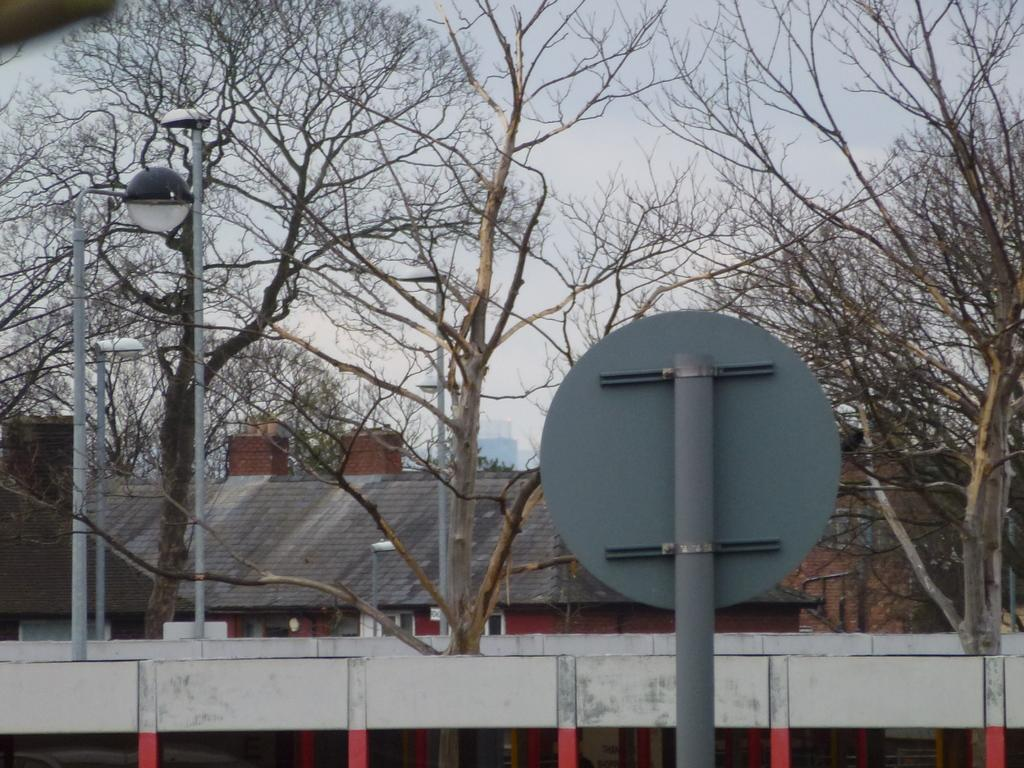What type of vegetation can be seen in the image? There are trees in the image. What structures are present in the image? There are poles in the image. What type of building is located at the bottom of the image? There is a house at the bottom of the image. What is visible in the background of the image? The sky is visible in the background of the image. Can you tell me how many toads are sitting on the poles in the image? There are no toads present in the image; it features trees, poles, a house, and the sky. What type of cheese is visible on the house in the image? There is no cheese present on the house in the image. 